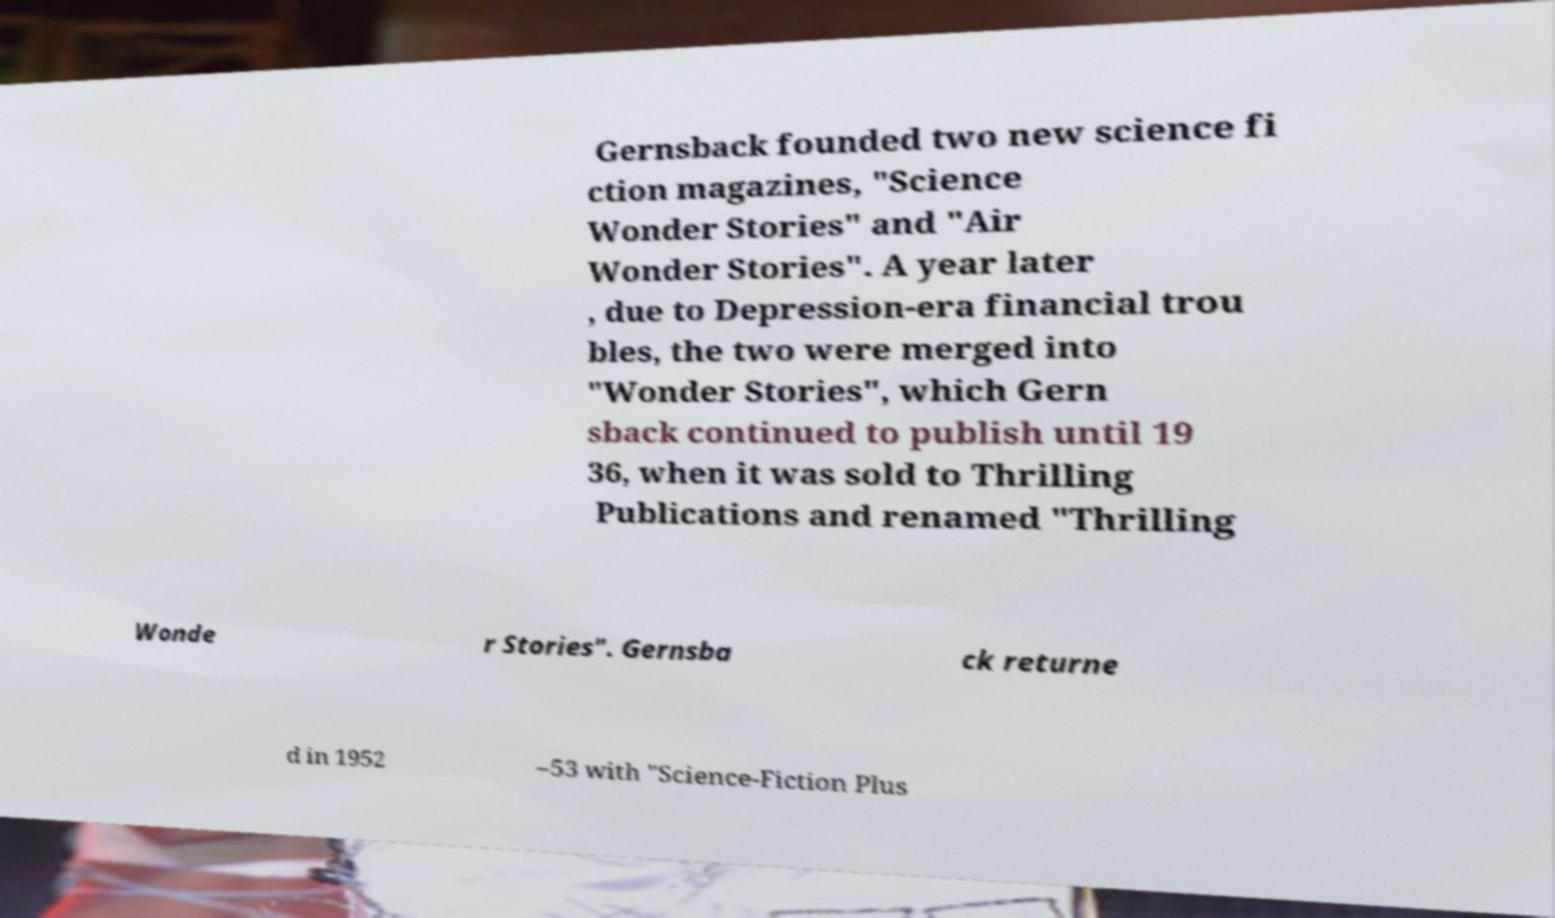There's text embedded in this image that I need extracted. Can you transcribe it verbatim? Gernsback founded two new science fi ction magazines, "Science Wonder Stories" and "Air Wonder Stories". A year later , due to Depression-era financial trou bles, the two were merged into "Wonder Stories", which Gern sback continued to publish until 19 36, when it was sold to Thrilling Publications and renamed "Thrilling Wonde r Stories". Gernsba ck returne d in 1952 –53 with "Science-Fiction Plus 